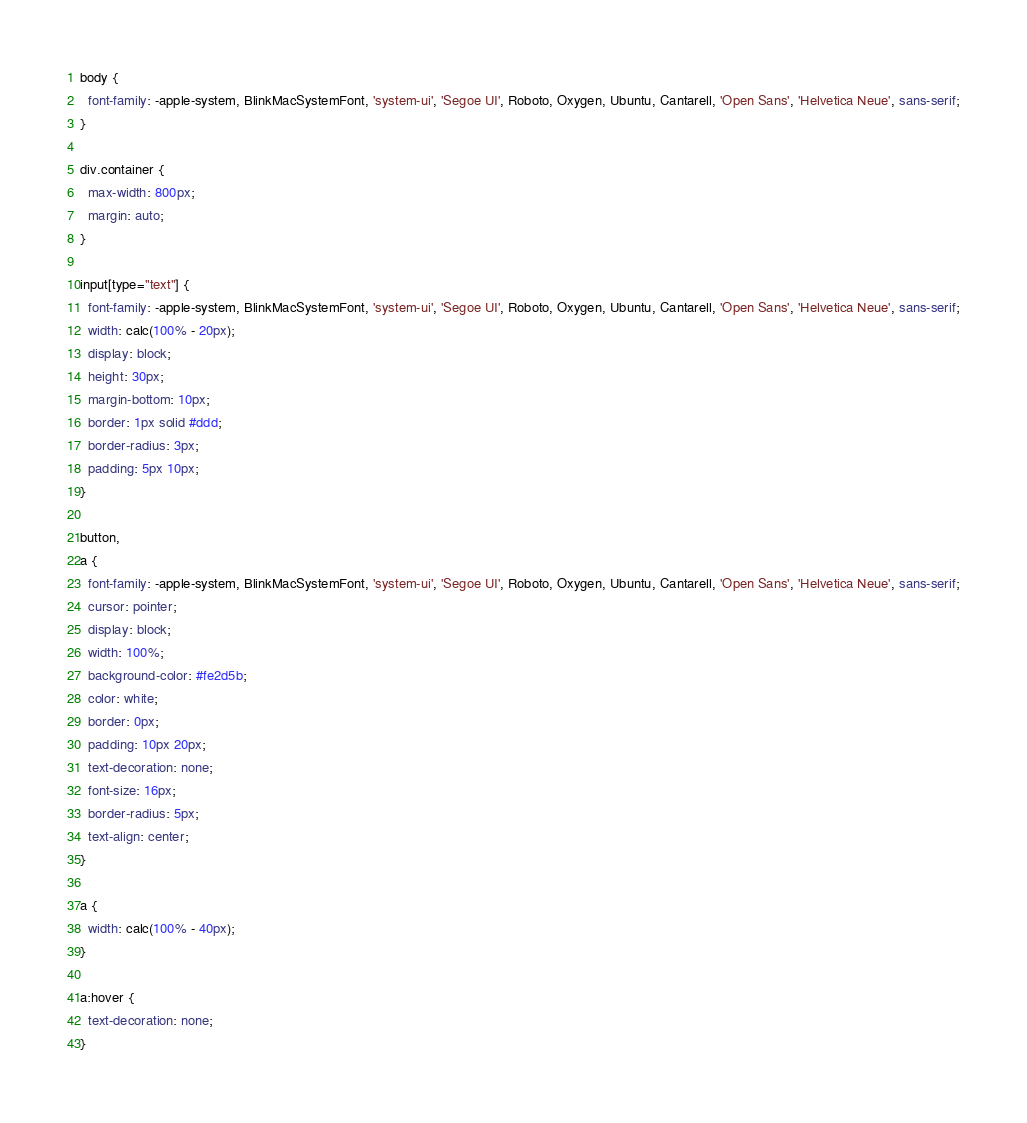<code> <loc_0><loc_0><loc_500><loc_500><_CSS_>body {
  font-family: -apple-system, BlinkMacSystemFont, 'system-ui', 'Segoe UI', Roboto, Oxygen, Ubuntu, Cantarell, 'Open Sans', 'Helvetica Neue', sans-serif;
}

div.container {
  max-width: 800px;
  margin: auto;
}

input[type="text"] {
  font-family: -apple-system, BlinkMacSystemFont, 'system-ui', 'Segoe UI', Roboto, Oxygen, Ubuntu, Cantarell, 'Open Sans', 'Helvetica Neue', sans-serif;
  width: calc(100% - 20px);
  display: block;
  height: 30px;
  margin-bottom: 10px;
  border: 1px solid #ddd;
  border-radius: 3px;
  padding: 5px 10px;
}

button,
a {
  font-family: -apple-system, BlinkMacSystemFont, 'system-ui', 'Segoe UI', Roboto, Oxygen, Ubuntu, Cantarell, 'Open Sans', 'Helvetica Neue', sans-serif;
  cursor: pointer;
  display: block;
  width: 100%;
  background-color: #fe2d5b;
  color: white;
  border: 0px;
  padding: 10px 20px;
  text-decoration: none;
  font-size: 16px;
  border-radius: 5px;
  text-align: center;
}

a {
  width: calc(100% - 40px);
}

a:hover {
  text-decoration: none;
}</code> 